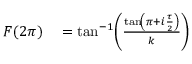<formula> <loc_0><loc_0><loc_500><loc_500>\begin{array} { r l } { F ( 2 \pi ) } & = \tan ^ { - 1 } \, \left ( \frac { { \tan \, \left ( \pi + i \frac { \tau } { 2 } \right ) } } { k } \right ) } \end{array}</formula> 